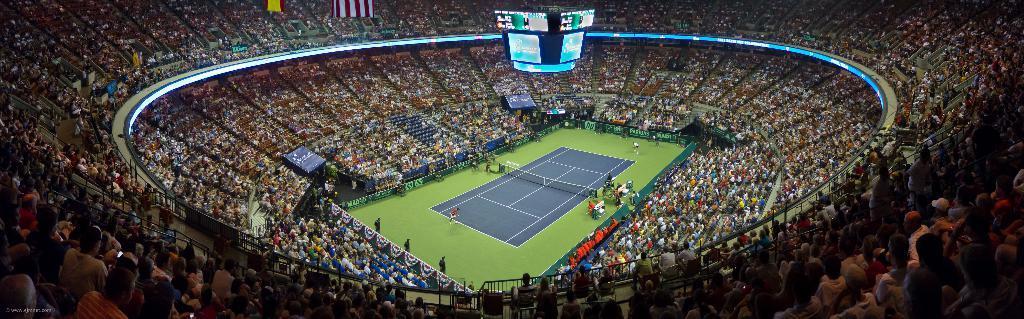Could you give a brief overview of what you see in this image? In this image I see the stadium and I see the tennis court over here and I see number of people who are sitting on chairs and I see the screens over here and I see the net over here. 